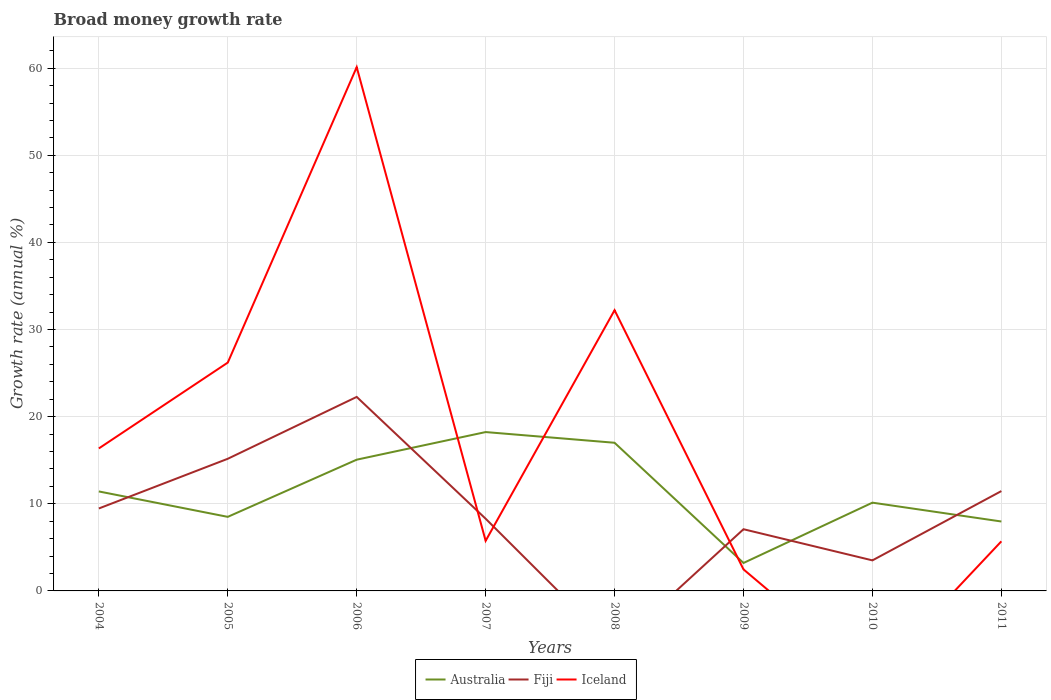Is the number of lines equal to the number of legend labels?
Provide a short and direct response. No. Across all years, what is the maximum growth rate in Australia?
Offer a terse response. 3.21. What is the total growth rate in Australia in the graph?
Ensure brevity in your answer.  -6.92. What is the difference between the highest and the second highest growth rate in Australia?
Make the answer very short. 15.03. Is the growth rate in Iceland strictly greater than the growth rate in Australia over the years?
Your answer should be very brief. No. How many lines are there?
Provide a succinct answer. 3. How many years are there in the graph?
Give a very brief answer. 8. Are the values on the major ticks of Y-axis written in scientific E-notation?
Offer a very short reply. No. Does the graph contain grids?
Your answer should be very brief. Yes. Where does the legend appear in the graph?
Give a very brief answer. Bottom center. How many legend labels are there?
Offer a terse response. 3. How are the legend labels stacked?
Offer a terse response. Horizontal. What is the title of the graph?
Give a very brief answer. Broad money growth rate. Does "Timor-Leste" appear as one of the legend labels in the graph?
Make the answer very short. No. What is the label or title of the Y-axis?
Provide a short and direct response. Growth rate (annual %). What is the Growth rate (annual %) of Australia in 2004?
Keep it short and to the point. 11.42. What is the Growth rate (annual %) of Fiji in 2004?
Make the answer very short. 9.46. What is the Growth rate (annual %) of Iceland in 2004?
Provide a short and direct response. 16.35. What is the Growth rate (annual %) of Australia in 2005?
Your answer should be very brief. 8.5. What is the Growth rate (annual %) in Fiji in 2005?
Your answer should be compact. 15.17. What is the Growth rate (annual %) of Iceland in 2005?
Your answer should be compact. 26.21. What is the Growth rate (annual %) of Australia in 2006?
Your answer should be compact. 15.06. What is the Growth rate (annual %) in Fiji in 2006?
Give a very brief answer. 22.27. What is the Growth rate (annual %) in Iceland in 2006?
Provide a succinct answer. 60.12. What is the Growth rate (annual %) in Australia in 2007?
Keep it short and to the point. 18.23. What is the Growth rate (annual %) of Fiji in 2007?
Ensure brevity in your answer.  8.29. What is the Growth rate (annual %) in Iceland in 2007?
Offer a terse response. 5.75. What is the Growth rate (annual %) of Australia in 2008?
Make the answer very short. 17. What is the Growth rate (annual %) in Iceland in 2008?
Give a very brief answer. 32.22. What is the Growth rate (annual %) in Australia in 2009?
Offer a very short reply. 3.21. What is the Growth rate (annual %) of Fiji in 2009?
Give a very brief answer. 7.08. What is the Growth rate (annual %) of Iceland in 2009?
Offer a terse response. 2.47. What is the Growth rate (annual %) of Australia in 2010?
Give a very brief answer. 10.13. What is the Growth rate (annual %) in Fiji in 2010?
Your answer should be very brief. 3.51. What is the Growth rate (annual %) of Iceland in 2010?
Make the answer very short. 0. What is the Growth rate (annual %) of Australia in 2011?
Ensure brevity in your answer.  7.97. What is the Growth rate (annual %) of Fiji in 2011?
Offer a very short reply. 11.46. What is the Growth rate (annual %) in Iceland in 2011?
Give a very brief answer. 5.69. Across all years, what is the maximum Growth rate (annual %) of Australia?
Give a very brief answer. 18.23. Across all years, what is the maximum Growth rate (annual %) in Fiji?
Give a very brief answer. 22.27. Across all years, what is the maximum Growth rate (annual %) in Iceland?
Give a very brief answer. 60.12. Across all years, what is the minimum Growth rate (annual %) in Australia?
Ensure brevity in your answer.  3.21. Across all years, what is the minimum Growth rate (annual %) of Iceland?
Offer a terse response. 0. What is the total Growth rate (annual %) of Australia in the graph?
Offer a terse response. 91.53. What is the total Growth rate (annual %) in Fiji in the graph?
Provide a short and direct response. 77.23. What is the total Growth rate (annual %) of Iceland in the graph?
Give a very brief answer. 148.81. What is the difference between the Growth rate (annual %) of Australia in 2004 and that in 2005?
Offer a terse response. 2.92. What is the difference between the Growth rate (annual %) of Fiji in 2004 and that in 2005?
Keep it short and to the point. -5.71. What is the difference between the Growth rate (annual %) of Iceland in 2004 and that in 2005?
Keep it short and to the point. -9.85. What is the difference between the Growth rate (annual %) of Australia in 2004 and that in 2006?
Provide a succinct answer. -3.64. What is the difference between the Growth rate (annual %) in Fiji in 2004 and that in 2006?
Offer a very short reply. -12.81. What is the difference between the Growth rate (annual %) in Iceland in 2004 and that in 2006?
Keep it short and to the point. -43.77. What is the difference between the Growth rate (annual %) of Australia in 2004 and that in 2007?
Give a very brief answer. -6.81. What is the difference between the Growth rate (annual %) in Fiji in 2004 and that in 2007?
Ensure brevity in your answer.  1.17. What is the difference between the Growth rate (annual %) of Iceland in 2004 and that in 2007?
Offer a terse response. 10.6. What is the difference between the Growth rate (annual %) in Australia in 2004 and that in 2008?
Make the answer very short. -5.59. What is the difference between the Growth rate (annual %) in Iceland in 2004 and that in 2008?
Provide a short and direct response. -15.87. What is the difference between the Growth rate (annual %) of Australia in 2004 and that in 2009?
Provide a short and direct response. 8.21. What is the difference between the Growth rate (annual %) in Fiji in 2004 and that in 2009?
Offer a very short reply. 2.38. What is the difference between the Growth rate (annual %) in Iceland in 2004 and that in 2009?
Ensure brevity in your answer.  13.88. What is the difference between the Growth rate (annual %) in Australia in 2004 and that in 2010?
Give a very brief answer. 1.29. What is the difference between the Growth rate (annual %) of Fiji in 2004 and that in 2010?
Keep it short and to the point. 5.96. What is the difference between the Growth rate (annual %) in Australia in 2004 and that in 2011?
Offer a very short reply. 3.45. What is the difference between the Growth rate (annual %) of Fiji in 2004 and that in 2011?
Provide a short and direct response. -2. What is the difference between the Growth rate (annual %) in Iceland in 2004 and that in 2011?
Make the answer very short. 10.66. What is the difference between the Growth rate (annual %) of Australia in 2005 and that in 2006?
Offer a very short reply. -6.56. What is the difference between the Growth rate (annual %) in Fiji in 2005 and that in 2006?
Give a very brief answer. -7.1. What is the difference between the Growth rate (annual %) in Iceland in 2005 and that in 2006?
Offer a very short reply. -33.91. What is the difference between the Growth rate (annual %) in Australia in 2005 and that in 2007?
Offer a very short reply. -9.73. What is the difference between the Growth rate (annual %) in Fiji in 2005 and that in 2007?
Give a very brief answer. 6.88. What is the difference between the Growth rate (annual %) of Iceland in 2005 and that in 2007?
Keep it short and to the point. 20.46. What is the difference between the Growth rate (annual %) in Australia in 2005 and that in 2008?
Offer a very short reply. -8.5. What is the difference between the Growth rate (annual %) in Iceland in 2005 and that in 2008?
Offer a terse response. -6.01. What is the difference between the Growth rate (annual %) in Australia in 2005 and that in 2009?
Give a very brief answer. 5.29. What is the difference between the Growth rate (annual %) in Fiji in 2005 and that in 2009?
Make the answer very short. 8.09. What is the difference between the Growth rate (annual %) of Iceland in 2005 and that in 2009?
Keep it short and to the point. 23.74. What is the difference between the Growth rate (annual %) in Australia in 2005 and that in 2010?
Keep it short and to the point. -1.63. What is the difference between the Growth rate (annual %) of Fiji in 2005 and that in 2010?
Offer a terse response. 11.66. What is the difference between the Growth rate (annual %) in Australia in 2005 and that in 2011?
Offer a very short reply. 0.53. What is the difference between the Growth rate (annual %) of Fiji in 2005 and that in 2011?
Keep it short and to the point. 3.71. What is the difference between the Growth rate (annual %) in Iceland in 2005 and that in 2011?
Keep it short and to the point. 20.51. What is the difference between the Growth rate (annual %) in Australia in 2006 and that in 2007?
Your answer should be very brief. -3.17. What is the difference between the Growth rate (annual %) in Fiji in 2006 and that in 2007?
Provide a succinct answer. 13.98. What is the difference between the Growth rate (annual %) of Iceland in 2006 and that in 2007?
Ensure brevity in your answer.  54.37. What is the difference between the Growth rate (annual %) of Australia in 2006 and that in 2008?
Give a very brief answer. -1.94. What is the difference between the Growth rate (annual %) of Iceland in 2006 and that in 2008?
Provide a succinct answer. 27.9. What is the difference between the Growth rate (annual %) in Australia in 2006 and that in 2009?
Your answer should be very brief. 11.86. What is the difference between the Growth rate (annual %) of Fiji in 2006 and that in 2009?
Ensure brevity in your answer.  15.19. What is the difference between the Growth rate (annual %) of Iceland in 2006 and that in 2009?
Provide a short and direct response. 57.65. What is the difference between the Growth rate (annual %) in Australia in 2006 and that in 2010?
Keep it short and to the point. 4.93. What is the difference between the Growth rate (annual %) of Fiji in 2006 and that in 2010?
Provide a short and direct response. 18.76. What is the difference between the Growth rate (annual %) of Australia in 2006 and that in 2011?
Your answer should be compact. 7.1. What is the difference between the Growth rate (annual %) of Fiji in 2006 and that in 2011?
Your answer should be compact. 10.81. What is the difference between the Growth rate (annual %) of Iceland in 2006 and that in 2011?
Make the answer very short. 54.43. What is the difference between the Growth rate (annual %) in Australia in 2007 and that in 2008?
Keep it short and to the point. 1.23. What is the difference between the Growth rate (annual %) in Iceland in 2007 and that in 2008?
Provide a succinct answer. -26.47. What is the difference between the Growth rate (annual %) in Australia in 2007 and that in 2009?
Your answer should be compact. 15.03. What is the difference between the Growth rate (annual %) of Fiji in 2007 and that in 2009?
Give a very brief answer. 1.21. What is the difference between the Growth rate (annual %) of Iceland in 2007 and that in 2009?
Provide a succinct answer. 3.28. What is the difference between the Growth rate (annual %) of Australia in 2007 and that in 2010?
Give a very brief answer. 8.1. What is the difference between the Growth rate (annual %) of Fiji in 2007 and that in 2010?
Your answer should be very brief. 4.78. What is the difference between the Growth rate (annual %) in Australia in 2007 and that in 2011?
Offer a very short reply. 10.27. What is the difference between the Growth rate (annual %) of Fiji in 2007 and that in 2011?
Give a very brief answer. -3.17. What is the difference between the Growth rate (annual %) in Iceland in 2007 and that in 2011?
Provide a short and direct response. 0.06. What is the difference between the Growth rate (annual %) in Australia in 2008 and that in 2009?
Ensure brevity in your answer.  13.8. What is the difference between the Growth rate (annual %) of Iceland in 2008 and that in 2009?
Give a very brief answer. 29.75. What is the difference between the Growth rate (annual %) of Australia in 2008 and that in 2010?
Make the answer very short. 6.87. What is the difference between the Growth rate (annual %) of Australia in 2008 and that in 2011?
Offer a terse response. 9.04. What is the difference between the Growth rate (annual %) of Iceland in 2008 and that in 2011?
Your answer should be compact. 26.53. What is the difference between the Growth rate (annual %) in Australia in 2009 and that in 2010?
Your answer should be very brief. -6.92. What is the difference between the Growth rate (annual %) in Fiji in 2009 and that in 2010?
Your answer should be compact. 3.58. What is the difference between the Growth rate (annual %) of Australia in 2009 and that in 2011?
Give a very brief answer. -4.76. What is the difference between the Growth rate (annual %) of Fiji in 2009 and that in 2011?
Provide a succinct answer. -4.38. What is the difference between the Growth rate (annual %) in Iceland in 2009 and that in 2011?
Provide a succinct answer. -3.22. What is the difference between the Growth rate (annual %) of Australia in 2010 and that in 2011?
Ensure brevity in your answer.  2.16. What is the difference between the Growth rate (annual %) of Fiji in 2010 and that in 2011?
Offer a terse response. -7.95. What is the difference between the Growth rate (annual %) of Australia in 2004 and the Growth rate (annual %) of Fiji in 2005?
Your answer should be compact. -3.75. What is the difference between the Growth rate (annual %) in Australia in 2004 and the Growth rate (annual %) in Iceland in 2005?
Keep it short and to the point. -14.79. What is the difference between the Growth rate (annual %) in Fiji in 2004 and the Growth rate (annual %) in Iceland in 2005?
Offer a terse response. -16.74. What is the difference between the Growth rate (annual %) of Australia in 2004 and the Growth rate (annual %) of Fiji in 2006?
Keep it short and to the point. -10.85. What is the difference between the Growth rate (annual %) in Australia in 2004 and the Growth rate (annual %) in Iceland in 2006?
Offer a terse response. -48.7. What is the difference between the Growth rate (annual %) of Fiji in 2004 and the Growth rate (annual %) of Iceland in 2006?
Give a very brief answer. -50.66. What is the difference between the Growth rate (annual %) of Australia in 2004 and the Growth rate (annual %) of Fiji in 2007?
Offer a terse response. 3.13. What is the difference between the Growth rate (annual %) in Australia in 2004 and the Growth rate (annual %) in Iceland in 2007?
Provide a succinct answer. 5.67. What is the difference between the Growth rate (annual %) in Fiji in 2004 and the Growth rate (annual %) in Iceland in 2007?
Keep it short and to the point. 3.71. What is the difference between the Growth rate (annual %) of Australia in 2004 and the Growth rate (annual %) of Iceland in 2008?
Keep it short and to the point. -20.8. What is the difference between the Growth rate (annual %) in Fiji in 2004 and the Growth rate (annual %) in Iceland in 2008?
Offer a very short reply. -22.76. What is the difference between the Growth rate (annual %) of Australia in 2004 and the Growth rate (annual %) of Fiji in 2009?
Your answer should be compact. 4.34. What is the difference between the Growth rate (annual %) in Australia in 2004 and the Growth rate (annual %) in Iceland in 2009?
Your response must be concise. 8.95. What is the difference between the Growth rate (annual %) in Fiji in 2004 and the Growth rate (annual %) in Iceland in 2009?
Make the answer very short. 6.99. What is the difference between the Growth rate (annual %) in Australia in 2004 and the Growth rate (annual %) in Fiji in 2010?
Ensure brevity in your answer.  7.91. What is the difference between the Growth rate (annual %) in Australia in 2004 and the Growth rate (annual %) in Fiji in 2011?
Your answer should be very brief. -0.04. What is the difference between the Growth rate (annual %) in Australia in 2004 and the Growth rate (annual %) in Iceland in 2011?
Your response must be concise. 5.73. What is the difference between the Growth rate (annual %) of Fiji in 2004 and the Growth rate (annual %) of Iceland in 2011?
Your response must be concise. 3.77. What is the difference between the Growth rate (annual %) in Australia in 2005 and the Growth rate (annual %) in Fiji in 2006?
Your answer should be very brief. -13.77. What is the difference between the Growth rate (annual %) in Australia in 2005 and the Growth rate (annual %) in Iceland in 2006?
Make the answer very short. -51.62. What is the difference between the Growth rate (annual %) in Fiji in 2005 and the Growth rate (annual %) in Iceland in 2006?
Your response must be concise. -44.95. What is the difference between the Growth rate (annual %) in Australia in 2005 and the Growth rate (annual %) in Fiji in 2007?
Provide a short and direct response. 0.21. What is the difference between the Growth rate (annual %) in Australia in 2005 and the Growth rate (annual %) in Iceland in 2007?
Provide a short and direct response. 2.75. What is the difference between the Growth rate (annual %) of Fiji in 2005 and the Growth rate (annual %) of Iceland in 2007?
Your answer should be very brief. 9.42. What is the difference between the Growth rate (annual %) in Australia in 2005 and the Growth rate (annual %) in Iceland in 2008?
Give a very brief answer. -23.72. What is the difference between the Growth rate (annual %) in Fiji in 2005 and the Growth rate (annual %) in Iceland in 2008?
Give a very brief answer. -17.05. What is the difference between the Growth rate (annual %) in Australia in 2005 and the Growth rate (annual %) in Fiji in 2009?
Your response must be concise. 1.42. What is the difference between the Growth rate (annual %) in Australia in 2005 and the Growth rate (annual %) in Iceland in 2009?
Keep it short and to the point. 6.03. What is the difference between the Growth rate (annual %) in Fiji in 2005 and the Growth rate (annual %) in Iceland in 2009?
Make the answer very short. 12.7. What is the difference between the Growth rate (annual %) in Australia in 2005 and the Growth rate (annual %) in Fiji in 2010?
Give a very brief answer. 4.99. What is the difference between the Growth rate (annual %) in Australia in 2005 and the Growth rate (annual %) in Fiji in 2011?
Ensure brevity in your answer.  -2.96. What is the difference between the Growth rate (annual %) of Australia in 2005 and the Growth rate (annual %) of Iceland in 2011?
Your answer should be compact. 2.81. What is the difference between the Growth rate (annual %) in Fiji in 2005 and the Growth rate (annual %) in Iceland in 2011?
Make the answer very short. 9.47. What is the difference between the Growth rate (annual %) of Australia in 2006 and the Growth rate (annual %) of Fiji in 2007?
Give a very brief answer. 6.77. What is the difference between the Growth rate (annual %) in Australia in 2006 and the Growth rate (annual %) in Iceland in 2007?
Your answer should be very brief. 9.31. What is the difference between the Growth rate (annual %) in Fiji in 2006 and the Growth rate (annual %) in Iceland in 2007?
Keep it short and to the point. 16.52. What is the difference between the Growth rate (annual %) in Australia in 2006 and the Growth rate (annual %) in Iceland in 2008?
Give a very brief answer. -17.16. What is the difference between the Growth rate (annual %) of Fiji in 2006 and the Growth rate (annual %) of Iceland in 2008?
Give a very brief answer. -9.95. What is the difference between the Growth rate (annual %) in Australia in 2006 and the Growth rate (annual %) in Fiji in 2009?
Offer a terse response. 7.98. What is the difference between the Growth rate (annual %) in Australia in 2006 and the Growth rate (annual %) in Iceland in 2009?
Provide a short and direct response. 12.59. What is the difference between the Growth rate (annual %) of Fiji in 2006 and the Growth rate (annual %) of Iceland in 2009?
Your answer should be very brief. 19.8. What is the difference between the Growth rate (annual %) of Australia in 2006 and the Growth rate (annual %) of Fiji in 2010?
Your response must be concise. 11.56. What is the difference between the Growth rate (annual %) of Australia in 2006 and the Growth rate (annual %) of Fiji in 2011?
Give a very brief answer. 3.6. What is the difference between the Growth rate (annual %) in Australia in 2006 and the Growth rate (annual %) in Iceland in 2011?
Ensure brevity in your answer.  9.37. What is the difference between the Growth rate (annual %) of Fiji in 2006 and the Growth rate (annual %) of Iceland in 2011?
Your response must be concise. 16.57. What is the difference between the Growth rate (annual %) of Australia in 2007 and the Growth rate (annual %) of Iceland in 2008?
Keep it short and to the point. -13.99. What is the difference between the Growth rate (annual %) of Fiji in 2007 and the Growth rate (annual %) of Iceland in 2008?
Offer a very short reply. -23.93. What is the difference between the Growth rate (annual %) of Australia in 2007 and the Growth rate (annual %) of Fiji in 2009?
Keep it short and to the point. 11.15. What is the difference between the Growth rate (annual %) in Australia in 2007 and the Growth rate (annual %) in Iceland in 2009?
Your answer should be compact. 15.76. What is the difference between the Growth rate (annual %) in Fiji in 2007 and the Growth rate (annual %) in Iceland in 2009?
Your answer should be very brief. 5.82. What is the difference between the Growth rate (annual %) of Australia in 2007 and the Growth rate (annual %) of Fiji in 2010?
Offer a very short reply. 14.73. What is the difference between the Growth rate (annual %) of Australia in 2007 and the Growth rate (annual %) of Fiji in 2011?
Your response must be concise. 6.77. What is the difference between the Growth rate (annual %) of Australia in 2007 and the Growth rate (annual %) of Iceland in 2011?
Keep it short and to the point. 12.54. What is the difference between the Growth rate (annual %) of Fiji in 2007 and the Growth rate (annual %) of Iceland in 2011?
Your answer should be very brief. 2.6. What is the difference between the Growth rate (annual %) in Australia in 2008 and the Growth rate (annual %) in Fiji in 2009?
Provide a succinct answer. 9.92. What is the difference between the Growth rate (annual %) in Australia in 2008 and the Growth rate (annual %) in Iceland in 2009?
Your answer should be very brief. 14.53. What is the difference between the Growth rate (annual %) of Australia in 2008 and the Growth rate (annual %) of Fiji in 2010?
Offer a very short reply. 13.5. What is the difference between the Growth rate (annual %) in Australia in 2008 and the Growth rate (annual %) in Fiji in 2011?
Make the answer very short. 5.54. What is the difference between the Growth rate (annual %) of Australia in 2008 and the Growth rate (annual %) of Iceland in 2011?
Your answer should be very brief. 11.31. What is the difference between the Growth rate (annual %) in Australia in 2009 and the Growth rate (annual %) in Fiji in 2010?
Provide a succinct answer. -0.3. What is the difference between the Growth rate (annual %) of Australia in 2009 and the Growth rate (annual %) of Fiji in 2011?
Make the answer very short. -8.25. What is the difference between the Growth rate (annual %) in Australia in 2009 and the Growth rate (annual %) in Iceland in 2011?
Offer a very short reply. -2.49. What is the difference between the Growth rate (annual %) of Fiji in 2009 and the Growth rate (annual %) of Iceland in 2011?
Give a very brief answer. 1.39. What is the difference between the Growth rate (annual %) in Australia in 2010 and the Growth rate (annual %) in Fiji in 2011?
Offer a terse response. -1.33. What is the difference between the Growth rate (annual %) in Australia in 2010 and the Growth rate (annual %) in Iceland in 2011?
Your response must be concise. 4.44. What is the difference between the Growth rate (annual %) in Fiji in 2010 and the Growth rate (annual %) in Iceland in 2011?
Your answer should be compact. -2.19. What is the average Growth rate (annual %) of Australia per year?
Provide a short and direct response. 11.44. What is the average Growth rate (annual %) in Fiji per year?
Give a very brief answer. 9.65. What is the average Growth rate (annual %) of Iceland per year?
Give a very brief answer. 18.6. In the year 2004, what is the difference between the Growth rate (annual %) of Australia and Growth rate (annual %) of Fiji?
Keep it short and to the point. 1.96. In the year 2004, what is the difference between the Growth rate (annual %) of Australia and Growth rate (annual %) of Iceland?
Make the answer very short. -4.94. In the year 2004, what is the difference between the Growth rate (annual %) in Fiji and Growth rate (annual %) in Iceland?
Provide a succinct answer. -6.89. In the year 2005, what is the difference between the Growth rate (annual %) in Australia and Growth rate (annual %) in Fiji?
Provide a short and direct response. -6.67. In the year 2005, what is the difference between the Growth rate (annual %) of Australia and Growth rate (annual %) of Iceland?
Provide a short and direct response. -17.71. In the year 2005, what is the difference between the Growth rate (annual %) of Fiji and Growth rate (annual %) of Iceland?
Offer a very short reply. -11.04. In the year 2006, what is the difference between the Growth rate (annual %) of Australia and Growth rate (annual %) of Fiji?
Your answer should be compact. -7.2. In the year 2006, what is the difference between the Growth rate (annual %) of Australia and Growth rate (annual %) of Iceland?
Provide a succinct answer. -45.06. In the year 2006, what is the difference between the Growth rate (annual %) in Fiji and Growth rate (annual %) in Iceland?
Your answer should be compact. -37.85. In the year 2007, what is the difference between the Growth rate (annual %) in Australia and Growth rate (annual %) in Fiji?
Provide a succinct answer. 9.94. In the year 2007, what is the difference between the Growth rate (annual %) in Australia and Growth rate (annual %) in Iceland?
Provide a short and direct response. 12.48. In the year 2007, what is the difference between the Growth rate (annual %) of Fiji and Growth rate (annual %) of Iceland?
Ensure brevity in your answer.  2.54. In the year 2008, what is the difference between the Growth rate (annual %) of Australia and Growth rate (annual %) of Iceland?
Your response must be concise. -15.22. In the year 2009, what is the difference between the Growth rate (annual %) of Australia and Growth rate (annual %) of Fiji?
Offer a terse response. -3.87. In the year 2009, what is the difference between the Growth rate (annual %) of Australia and Growth rate (annual %) of Iceland?
Your answer should be compact. 0.74. In the year 2009, what is the difference between the Growth rate (annual %) of Fiji and Growth rate (annual %) of Iceland?
Offer a terse response. 4.61. In the year 2010, what is the difference between the Growth rate (annual %) of Australia and Growth rate (annual %) of Fiji?
Ensure brevity in your answer.  6.62. In the year 2011, what is the difference between the Growth rate (annual %) of Australia and Growth rate (annual %) of Fiji?
Give a very brief answer. -3.49. In the year 2011, what is the difference between the Growth rate (annual %) in Australia and Growth rate (annual %) in Iceland?
Give a very brief answer. 2.27. In the year 2011, what is the difference between the Growth rate (annual %) of Fiji and Growth rate (annual %) of Iceland?
Your response must be concise. 5.77. What is the ratio of the Growth rate (annual %) in Australia in 2004 to that in 2005?
Make the answer very short. 1.34. What is the ratio of the Growth rate (annual %) of Fiji in 2004 to that in 2005?
Give a very brief answer. 0.62. What is the ratio of the Growth rate (annual %) of Iceland in 2004 to that in 2005?
Offer a terse response. 0.62. What is the ratio of the Growth rate (annual %) in Australia in 2004 to that in 2006?
Ensure brevity in your answer.  0.76. What is the ratio of the Growth rate (annual %) of Fiji in 2004 to that in 2006?
Your answer should be compact. 0.42. What is the ratio of the Growth rate (annual %) of Iceland in 2004 to that in 2006?
Your answer should be compact. 0.27. What is the ratio of the Growth rate (annual %) in Australia in 2004 to that in 2007?
Give a very brief answer. 0.63. What is the ratio of the Growth rate (annual %) of Fiji in 2004 to that in 2007?
Provide a succinct answer. 1.14. What is the ratio of the Growth rate (annual %) of Iceland in 2004 to that in 2007?
Your response must be concise. 2.84. What is the ratio of the Growth rate (annual %) in Australia in 2004 to that in 2008?
Give a very brief answer. 0.67. What is the ratio of the Growth rate (annual %) of Iceland in 2004 to that in 2008?
Offer a very short reply. 0.51. What is the ratio of the Growth rate (annual %) in Australia in 2004 to that in 2009?
Provide a short and direct response. 3.56. What is the ratio of the Growth rate (annual %) of Fiji in 2004 to that in 2009?
Keep it short and to the point. 1.34. What is the ratio of the Growth rate (annual %) of Iceland in 2004 to that in 2009?
Offer a very short reply. 6.62. What is the ratio of the Growth rate (annual %) in Australia in 2004 to that in 2010?
Make the answer very short. 1.13. What is the ratio of the Growth rate (annual %) of Fiji in 2004 to that in 2010?
Provide a short and direct response. 2.7. What is the ratio of the Growth rate (annual %) in Australia in 2004 to that in 2011?
Provide a short and direct response. 1.43. What is the ratio of the Growth rate (annual %) in Fiji in 2004 to that in 2011?
Give a very brief answer. 0.83. What is the ratio of the Growth rate (annual %) of Iceland in 2004 to that in 2011?
Offer a very short reply. 2.87. What is the ratio of the Growth rate (annual %) of Australia in 2005 to that in 2006?
Your answer should be compact. 0.56. What is the ratio of the Growth rate (annual %) in Fiji in 2005 to that in 2006?
Ensure brevity in your answer.  0.68. What is the ratio of the Growth rate (annual %) of Iceland in 2005 to that in 2006?
Provide a succinct answer. 0.44. What is the ratio of the Growth rate (annual %) in Australia in 2005 to that in 2007?
Provide a short and direct response. 0.47. What is the ratio of the Growth rate (annual %) in Fiji in 2005 to that in 2007?
Ensure brevity in your answer.  1.83. What is the ratio of the Growth rate (annual %) in Iceland in 2005 to that in 2007?
Make the answer very short. 4.56. What is the ratio of the Growth rate (annual %) in Australia in 2005 to that in 2008?
Your answer should be very brief. 0.5. What is the ratio of the Growth rate (annual %) in Iceland in 2005 to that in 2008?
Offer a terse response. 0.81. What is the ratio of the Growth rate (annual %) in Australia in 2005 to that in 2009?
Offer a terse response. 2.65. What is the ratio of the Growth rate (annual %) of Fiji in 2005 to that in 2009?
Keep it short and to the point. 2.14. What is the ratio of the Growth rate (annual %) in Iceland in 2005 to that in 2009?
Keep it short and to the point. 10.61. What is the ratio of the Growth rate (annual %) in Australia in 2005 to that in 2010?
Ensure brevity in your answer.  0.84. What is the ratio of the Growth rate (annual %) of Fiji in 2005 to that in 2010?
Your response must be concise. 4.33. What is the ratio of the Growth rate (annual %) of Australia in 2005 to that in 2011?
Offer a terse response. 1.07. What is the ratio of the Growth rate (annual %) in Fiji in 2005 to that in 2011?
Provide a succinct answer. 1.32. What is the ratio of the Growth rate (annual %) of Iceland in 2005 to that in 2011?
Make the answer very short. 4.6. What is the ratio of the Growth rate (annual %) in Australia in 2006 to that in 2007?
Offer a very short reply. 0.83. What is the ratio of the Growth rate (annual %) of Fiji in 2006 to that in 2007?
Your answer should be compact. 2.69. What is the ratio of the Growth rate (annual %) of Iceland in 2006 to that in 2007?
Offer a very short reply. 10.45. What is the ratio of the Growth rate (annual %) in Australia in 2006 to that in 2008?
Your answer should be compact. 0.89. What is the ratio of the Growth rate (annual %) of Iceland in 2006 to that in 2008?
Ensure brevity in your answer.  1.87. What is the ratio of the Growth rate (annual %) in Australia in 2006 to that in 2009?
Offer a terse response. 4.7. What is the ratio of the Growth rate (annual %) in Fiji in 2006 to that in 2009?
Your answer should be compact. 3.14. What is the ratio of the Growth rate (annual %) in Iceland in 2006 to that in 2009?
Offer a very short reply. 24.33. What is the ratio of the Growth rate (annual %) of Australia in 2006 to that in 2010?
Keep it short and to the point. 1.49. What is the ratio of the Growth rate (annual %) of Fiji in 2006 to that in 2010?
Your answer should be very brief. 6.35. What is the ratio of the Growth rate (annual %) in Australia in 2006 to that in 2011?
Provide a succinct answer. 1.89. What is the ratio of the Growth rate (annual %) of Fiji in 2006 to that in 2011?
Offer a very short reply. 1.94. What is the ratio of the Growth rate (annual %) in Iceland in 2006 to that in 2011?
Make the answer very short. 10.56. What is the ratio of the Growth rate (annual %) in Australia in 2007 to that in 2008?
Provide a succinct answer. 1.07. What is the ratio of the Growth rate (annual %) of Iceland in 2007 to that in 2008?
Your answer should be compact. 0.18. What is the ratio of the Growth rate (annual %) in Australia in 2007 to that in 2009?
Your answer should be compact. 5.68. What is the ratio of the Growth rate (annual %) in Fiji in 2007 to that in 2009?
Give a very brief answer. 1.17. What is the ratio of the Growth rate (annual %) of Iceland in 2007 to that in 2009?
Offer a very short reply. 2.33. What is the ratio of the Growth rate (annual %) of Australia in 2007 to that in 2010?
Your answer should be very brief. 1.8. What is the ratio of the Growth rate (annual %) in Fiji in 2007 to that in 2010?
Provide a short and direct response. 2.36. What is the ratio of the Growth rate (annual %) in Australia in 2007 to that in 2011?
Offer a very short reply. 2.29. What is the ratio of the Growth rate (annual %) of Fiji in 2007 to that in 2011?
Your answer should be very brief. 0.72. What is the ratio of the Growth rate (annual %) in Iceland in 2007 to that in 2011?
Give a very brief answer. 1.01. What is the ratio of the Growth rate (annual %) of Australia in 2008 to that in 2009?
Offer a very short reply. 5.3. What is the ratio of the Growth rate (annual %) in Iceland in 2008 to that in 2009?
Offer a very short reply. 13.04. What is the ratio of the Growth rate (annual %) in Australia in 2008 to that in 2010?
Provide a short and direct response. 1.68. What is the ratio of the Growth rate (annual %) of Australia in 2008 to that in 2011?
Make the answer very short. 2.13. What is the ratio of the Growth rate (annual %) of Iceland in 2008 to that in 2011?
Provide a succinct answer. 5.66. What is the ratio of the Growth rate (annual %) of Australia in 2009 to that in 2010?
Offer a very short reply. 0.32. What is the ratio of the Growth rate (annual %) in Fiji in 2009 to that in 2010?
Give a very brief answer. 2.02. What is the ratio of the Growth rate (annual %) of Australia in 2009 to that in 2011?
Keep it short and to the point. 0.4. What is the ratio of the Growth rate (annual %) of Fiji in 2009 to that in 2011?
Keep it short and to the point. 0.62. What is the ratio of the Growth rate (annual %) in Iceland in 2009 to that in 2011?
Your response must be concise. 0.43. What is the ratio of the Growth rate (annual %) in Australia in 2010 to that in 2011?
Provide a short and direct response. 1.27. What is the ratio of the Growth rate (annual %) of Fiji in 2010 to that in 2011?
Your answer should be very brief. 0.31. What is the difference between the highest and the second highest Growth rate (annual %) in Australia?
Offer a very short reply. 1.23. What is the difference between the highest and the second highest Growth rate (annual %) of Fiji?
Ensure brevity in your answer.  7.1. What is the difference between the highest and the second highest Growth rate (annual %) of Iceland?
Provide a succinct answer. 27.9. What is the difference between the highest and the lowest Growth rate (annual %) in Australia?
Offer a terse response. 15.03. What is the difference between the highest and the lowest Growth rate (annual %) of Fiji?
Ensure brevity in your answer.  22.27. What is the difference between the highest and the lowest Growth rate (annual %) of Iceland?
Give a very brief answer. 60.12. 